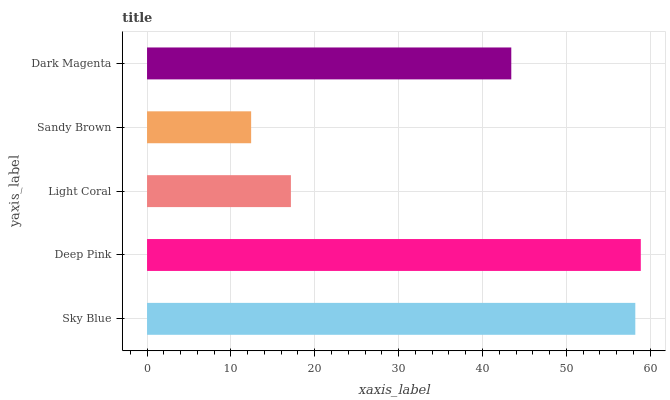Is Sandy Brown the minimum?
Answer yes or no. Yes. Is Deep Pink the maximum?
Answer yes or no. Yes. Is Light Coral the minimum?
Answer yes or no. No. Is Light Coral the maximum?
Answer yes or no. No. Is Deep Pink greater than Light Coral?
Answer yes or no. Yes. Is Light Coral less than Deep Pink?
Answer yes or no. Yes. Is Light Coral greater than Deep Pink?
Answer yes or no. No. Is Deep Pink less than Light Coral?
Answer yes or no. No. Is Dark Magenta the high median?
Answer yes or no. Yes. Is Dark Magenta the low median?
Answer yes or no. Yes. Is Sky Blue the high median?
Answer yes or no. No. Is Light Coral the low median?
Answer yes or no. No. 